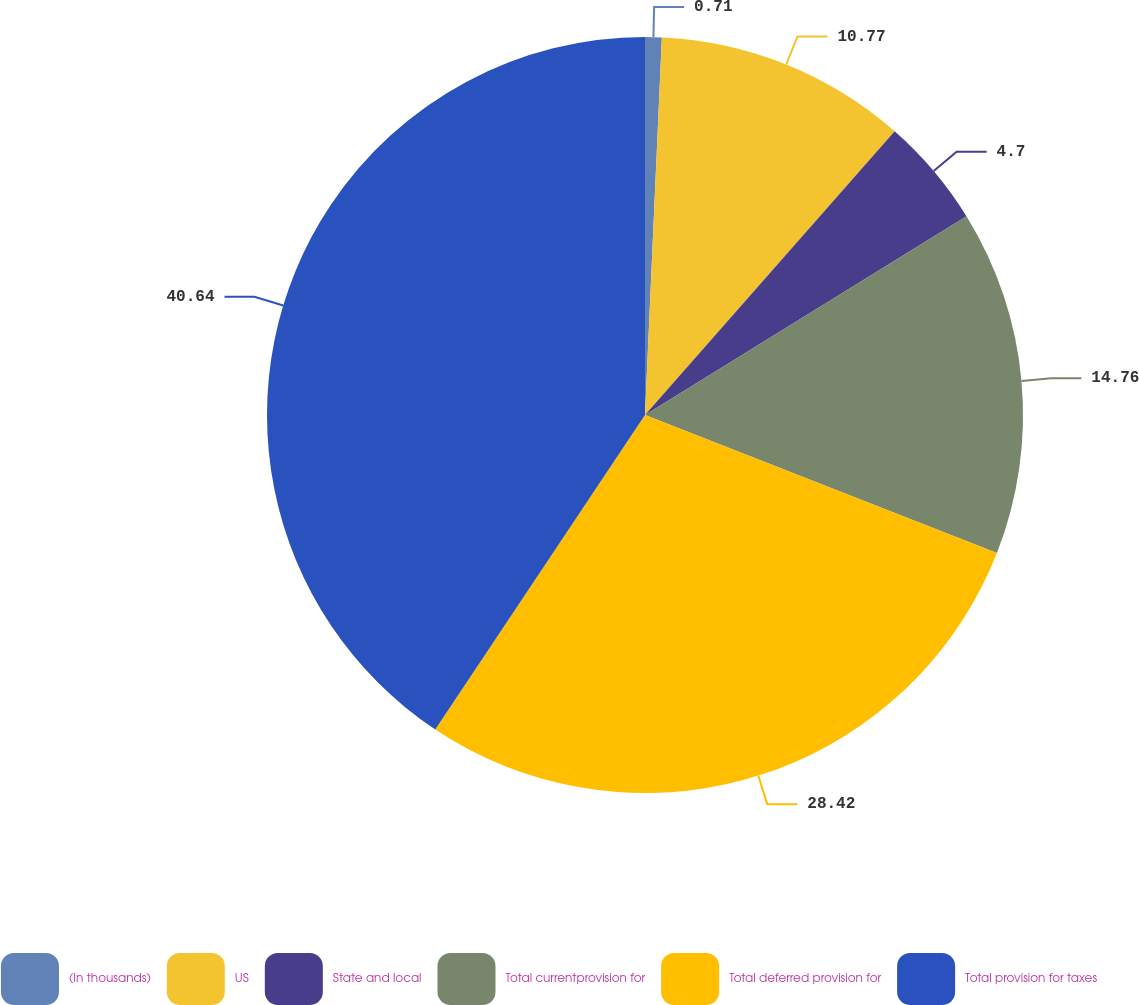Convert chart. <chart><loc_0><loc_0><loc_500><loc_500><pie_chart><fcel>(In thousands)<fcel>US<fcel>State and local<fcel>Total currentprovision for<fcel>Total deferred provision for<fcel>Total provision for taxes<nl><fcel>0.71%<fcel>10.77%<fcel>4.7%<fcel>14.76%<fcel>28.41%<fcel>40.63%<nl></chart> 